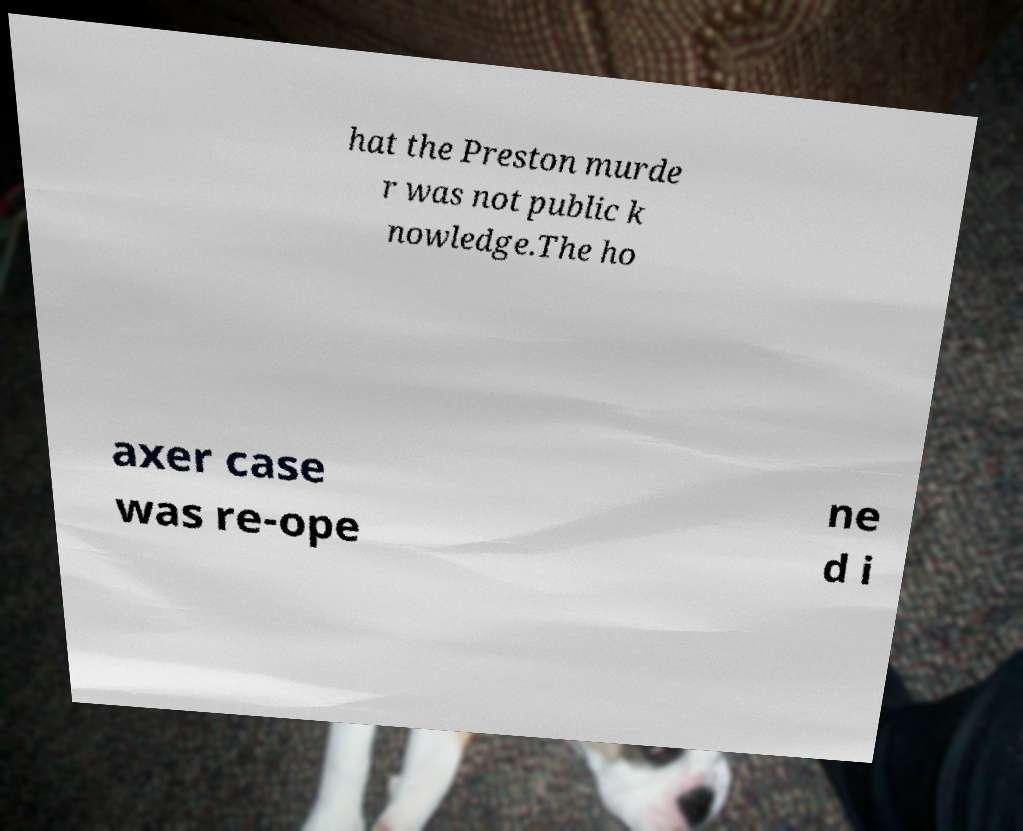Could you extract and type out the text from this image? hat the Preston murde r was not public k nowledge.The ho axer case was re-ope ne d i 